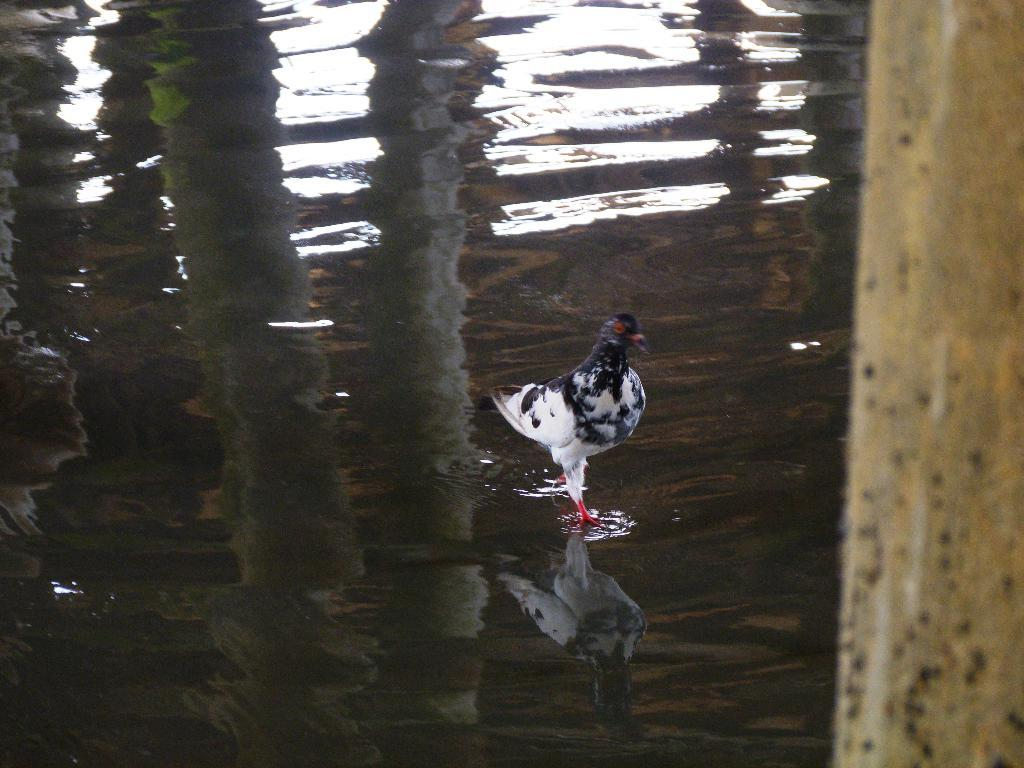What animal is present in the image? There is a hen in the image. What color is the hen in the image? The hen is in black and white color. Where is the hen located in the image? The hen is standing on the water. What can be seen to the right of the image? There is a pole to the right of the image. What letter is the hen holding in the image? There is no letter present in the image; it features a hen standing on the water. Can you see a yak in the image? There is no yak present in the image. 